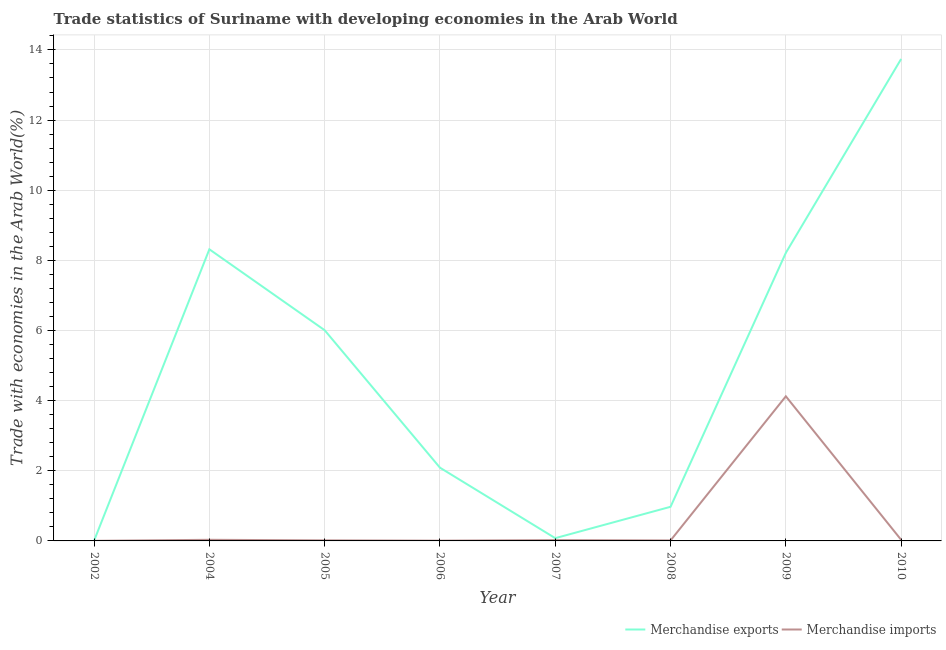How many different coloured lines are there?
Your answer should be very brief. 2. Does the line corresponding to merchandise imports intersect with the line corresponding to merchandise exports?
Offer a very short reply. No. Is the number of lines equal to the number of legend labels?
Provide a short and direct response. Yes. What is the merchandise imports in 2010?
Your response must be concise. 0.03. Across all years, what is the maximum merchandise imports?
Your answer should be compact. 4.12. Across all years, what is the minimum merchandise exports?
Your answer should be very brief. 0.01. In which year was the merchandise imports maximum?
Provide a short and direct response. 2009. In which year was the merchandise imports minimum?
Keep it short and to the point. 2002. What is the total merchandise imports in the graph?
Keep it short and to the point. 4.25. What is the difference between the merchandise imports in 2005 and that in 2006?
Your answer should be very brief. 0.01. What is the difference between the merchandise exports in 2008 and the merchandise imports in 2009?
Give a very brief answer. -3.15. What is the average merchandise exports per year?
Your answer should be compact. 4.93. In the year 2002, what is the difference between the merchandise exports and merchandise imports?
Provide a succinct answer. 0. In how many years, is the merchandise imports greater than 3.2 %?
Make the answer very short. 1. What is the ratio of the merchandise imports in 2005 to that in 2010?
Provide a short and direct response. 0.5. Is the merchandise imports in 2006 less than that in 2009?
Give a very brief answer. Yes. Is the difference between the merchandise imports in 2005 and 2006 greater than the difference between the merchandise exports in 2005 and 2006?
Keep it short and to the point. No. What is the difference between the highest and the second highest merchandise imports?
Provide a short and direct response. 4.09. What is the difference between the highest and the lowest merchandise imports?
Your answer should be very brief. 4.12. In how many years, is the merchandise imports greater than the average merchandise imports taken over all years?
Ensure brevity in your answer.  1. Does the merchandise imports monotonically increase over the years?
Your answer should be compact. No. Is the merchandise exports strictly greater than the merchandise imports over the years?
Your answer should be very brief. Yes. How many lines are there?
Provide a short and direct response. 2. How many years are there in the graph?
Offer a terse response. 8. Are the values on the major ticks of Y-axis written in scientific E-notation?
Keep it short and to the point. No. Does the graph contain any zero values?
Your response must be concise. No. Does the graph contain grids?
Provide a succinct answer. Yes. How many legend labels are there?
Provide a short and direct response. 2. What is the title of the graph?
Ensure brevity in your answer.  Trade statistics of Suriname with developing economies in the Arab World. Does "Under-five" appear as one of the legend labels in the graph?
Offer a terse response. No. What is the label or title of the X-axis?
Offer a very short reply. Year. What is the label or title of the Y-axis?
Offer a very short reply. Trade with economies in the Arab World(%). What is the Trade with economies in the Arab World(%) in Merchandise exports in 2002?
Offer a terse response. 0.01. What is the Trade with economies in the Arab World(%) in Merchandise imports in 2002?
Provide a succinct answer. 0. What is the Trade with economies in the Arab World(%) of Merchandise exports in 2004?
Provide a short and direct response. 8.32. What is the Trade with economies in the Arab World(%) of Merchandise imports in 2004?
Ensure brevity in your answer.  0.03. What is the Trade with economies in the Arab World(%) in Merchandise exports in 2005?
Keep it short and to the point. 6.01. What is the Trade with economies in the Arab World(%) in Merchandise imports in 2005?
Your response must be concise. 0.02. What is the Trade with economies in the Arab World(%) in Merchandise exports in 2006?
Your answer should be compact. 2.09. What is the Trade with economies in the Arab World(%) in Merchandise imports in 2006?
Provide a succinct answer. 0.01. What is the Trade with economies in the Arab World(%) in Merchandise exports in 2007?
Your response must be concise. 0.08. What is the Trade with economies in the Arab World(%) in Merchandise imports in 2007?
Your response must be concise. 0.02. What is the Trade with economies in the Arab World(%) in Merchandise exports in 2008?
Ensure brevity in your answer.  0.97. What is the Trade with economies in the Arab World(%) of Merchandise imports in 2008?
Provide a short and direct response. 0.01. What is the Trade with economies in the Arab World(%) of Merchandise exports in 2009?
Keep it short and to the point. 8.21. What is the Trade with economies in the Arab World(%) of Merchandise imports in 2009?
Your answer should be very brief. 4.12. What is the Trade with economies in the Arab World(%) of Merchandise exports in 2010?
Provide a short and direct response. 13.74. What is the Trade with economies in the Arab World(%) of Merchandise imports in 2010?
Keep it short and to the point. 0.03. Across all years, what is the maximum Trade with economies in the Arab World(%) in Merchandise exports?
Keep it short and to the point. 13.74. Across all years, what is the maximum Trade with economies in the Arab World(%) of Merchandise imports?
Your answer should be compact. 4.12. Across all years, what is the minimum Trade with economies in the Arab World(%) of Merchandise exports?
Offer a very short reply. 0.01. Across all years, what is the minimum Trade with economies in the Arab World(%) in Merchandise imports?
Provide a short and direct response. 0. What is the total Trade with economies in the Arab World(%) of Merchandise exports in the graph?
Ensure brevity in your answer.  39.43. What is the total Trade with economies in the Arab World(%) in Merchandise imports in the graph?
Make the answer very short. 4.25. What is the difference between the Trade with economies in the Arab World(%) in Merchandise exports in 2002 and that in 2004?
Make the answer very short. -8.31. What is the difference between the Trade with economies in the Arab World(%) of Merchandise imports in 2002 and that in 2004?
Ensure brevity in your answer.  -0.03. What is the difference between the Trade with economies in the Arab World(%) in Merchandise exports in 2002 and that in 2005?
Make the answer very short. -6. What is the difference between the Trade with economies in the Arab World(%) in Merchandise imports in 2002 and that in 2005?
Provide a succinct answer. -0.01. What is the difference between the Trade with economies in the Arab World(%) in Merchandise exports in 2002 and that in 2006?
Your answer should be compact. -2.08. What is the difference between the Trade with economies in the Arab World(%) in Merchandise imports in 2002 and that in 2006?
Keep it short and to the point. -0.01. What is the difference between the Trade with economies in the Arab World(%) in Merchandise exports in 2002 and that in 2007?
Give a very brief answer. -0.07. What is the difference between the Trade with economies in the Arab World(%) in Merchandise imports in 2002 and that in 2007?
Your answer should be compact. -0.02. What is the difference between the Trade with economies in the Arab World(%) of Merchandise exports in 2002 and that in 2008?
Ensure brevity in your answer.  -0.97. What is the difference between the Trade with economies in the Arab World(%) in Merchandise imports in 2002 and that in 2008?
Provide a succinct answer. -0.01. What is the difference between the Trade with economies in the Arab World(%) in Merchandise exports in 2002 and that in 2009?
Make the answer very short. -8.21. What is the difference between the Trade with economies in the Arab World(%) in Merchandise imports in 2002 and that in 2009?
Your answer should be compact. -4.12. What is the difference between the Trade with economies in the Arab World(%) in Merchandise exports in 2002 and that in 2010?
Give a very brief answer. -13.74. What is the difference between the Trade with economies in the Arab World(%) in Merchandise imports in 2002 and that in 2010?
Your response must be concise. -0.03. What is the difference between the Trade with economies in the Arab World(%) in Merchandise exports in 2004 and that in 2005?
Your answer should be very brief. 2.31. What is the difference between the Trade with economies in the Arab World(%) in Merchandise imports in 2004 and that in 2005?
Offer a terse response. 0.02. What is the difference between the Trade with economies in the Arab World(%) in Merchandise exports in 2004 and that in 2006?
Provide a short and direct response. 6.23. What is the difference between the Trade with economies in the Arab World(%) of Merchandise imports in 2004 and that in 2006?
Give a very brief answer. 0.02. What is the difference between the Trade with economies in the Arab World(%) in Merchandise exports in 2004 and that in 2007?
Offer a very short reply. 8.24. What is the difference between the Trade with economies in the Arab World(%) of Merchandise imports in 2004 and that in 2007?
Offer a very short reply. 0.01. What is the difference between the Trade with economies in the Arab World(%) of Merchandise exports in 2004 and that in 2008?
Give a very brief answer. 7.34. What is the difference between the Trade with economies in the Arab World(%) in Merchandise imports in 2004 and that in 2008?
Keep it short and to the point. 0.02. What is the difference between the Trade with economies in the Arab World(%) in Merchandise exports in 2004 and that in 2009?
Your answer should be compact. 0.1. What is the difference between the Trade with economies in the Arab World(%) of Merchandise imports in 2004 and that in 2009?
Provide a short and direct response. -4.09. What is the difference between the Trade with economies in the Arab World(%) of Merchandise exports in 2004 and that in 2010?
Give a very brief answer. -5.43. What is the difference between the Trade with economies in the Arab World(%) of Merchandise exports in 2005 and that in 2006?
Give a very brief answer. 3.92. What is the difference between the Trade with economies in the Arab World(%) of Merchandise imports in 2005 and that in 2006?
Keep it short and to the point. 0.01. What is the difference between the Trade with economies in the Arab World(%) in Merchandise exports in 2005 and that in 2007?
Provide a short and direct response. 5.93. What is the difference between the Trade with economies in the Arab World(%) of Merchandise imports in 2005 and that in 2007?
Your answer should be very brief. -0.01. What is the difference between the Trade with economies in the Arab World(%) of Merchandise exports in 2005 and that in 2008?
Ensure brevity in your answer.  5.03. What is the difference between the Trade with economies in the Arab World(%) of Merchandise imports in 2005 and that in 2008?
Provide a short and direct response. 0. What is the difference between the Trade with economies in the Arab World(%) of Merchandise exports in 2005 and that in 2009?
Offer a terse response. -2.21. What is the difference between the Trade with economies in the Arab World(%) of Merchandise imports in 2005 and that in 2009?
Offer a terse response. -4.11. What is the difference between the Trade with economies in the Arab World(%) of Merchandise exports in 2005 and that in 2010?
Keep it short and to the point. -7.73. What is the difference between the Trade with economies in the Arab World(%) of Merchandise imports in 2005 and that in 2010?
Your response must be concise. -0.02. What is the difference between the Trade with economies in the Arab World(%) of Merchandise exports in 2006 and that in 2007?
Offer a very short reply. 2.01. What is the difference between the Trade with economies in the Arab World(%) of Merchandise imports in 2006 and that in 2007?
Give a very brief answer. -0.02. What is the difference between the Trade with economies in the Arab World(%) in Merchandise exports in 2006 and that in 2008?
Offer a very short reply. 1.12. What is the difference between the Trade with economies in the Arab World(%) in Merchandise imports in 2006 and that in 2008?
Provide a succinct answer. -0.01. What is the difference between the Trade with economies in the Arab World(%) in Merchandise exports in 2006 and that in 2009?
Make the answer very short. -6.13. What is the difference between the Trade with economies in the Arab World(%) of Merchandise imports in 2006 and that in 2009?
Your answer should be very brief. -4.12. What is the difference between the Trade with economies in the Arab World(%) in Merchandise exports in 2006 and that in 2010?
Your answer should be compact. -11.65. What is the difference between the Trade with economies in the Arab World(%) in Merchandise imports in 2006 and that in 2010?
Provide a short and direct response. -0.02. What is the difference between the Trade with economies in the Arab World(%) of Merchandise exports in 2007 and that in 2008?
Give a very brief answer. -0.89. What is the difference between the Trade with economies in the Arab World(%) in Merchandise imports in 2007 and that in 2008?
Provide a short and direct response. 0.01. What is the difference between the Trade with economies in the Arab World(%) of Merchandise exports in 2007 and that in 2009?
Your response must be concise. -8.14. What is the difference between the Trade with economies in the Arab World(%) of Merchandise imports in 2007 and that in 2009?
Provide a succinct answer. -4.1. What is the difference between the Trade with economies in the Arab World(%) of Merchandise exports in 2007 and that in 2010?
Your response must be concise. -13.66. What is the difference between the Trade with economies in the Arab World(%) in Merchandise imports in 2007 and that in 2010?
Make the answer very short. -0.01. What is the difference between the Trade with economies in the Arab World(%) of Merchandise exports in 2008 and that in 2009?
Keep it short and to the point. -7.24. What is the difference between the Trade with economies in the Arab World(%) of Merchandise imports in 2008 and that in 2009?
Your answer should be very brief. -4.11. What is the difference between the Trade with economies in the Arab World(%) in Merchandise exports in 2008 and that in 2010?
Give a very brief answer. -12.77. What is the difference between the Trade with economies in the Arab World(%) in Merchandise imports in 2008 and that in 2010?
Your answer should be very brief. -0.02. What is the difference between the Trade with economies in the Arab World(%) of Merchandise exports in 2009 and that in 2010?
Your answer should be compact. -5.53. What is the difference between the Trade with economies in the Arab World(%) in Merchandise imports in 2009 and that in 2010?
Give a very brief answer. 4.09. What is the difference between the Trade with economies in the Arab World(%) of Merchandise exports in 2002 and the Trade with economies in the Arab World(%) of Merchandise imports in 2004?
Provide a short and direct response. -0.03. What is the difference between the Trade with economies in the Arab World(%) in Merchandise exports in 2002 and the Trade with economies in the Arab World(%) in Merchandise imports in 2005?
Keep it short and to the point. -0.01. What is the difference between the Trade with economies in the Arab World(%) of Merchandise exports in 2002 and the Trade with economies in the Arab World(%) of Merchandise imports in 2006?
Offer a very short reply. -0. What is the difference between the Trade with economies in the Arab World(%) in Merchandise exports in 2002 and the Trade with economies in the Arab World(%) in Merchandise imports in 2007?
Offer a terse response. -0.02. What is the difference between the Trade with economies in the Arab World(%) in Merchandise exports in 2002 and the Trade with economies in the Arab World(%) in Merchandise imports in 2008?
Make the answer very short. -0.01. What is the difference between the Trade with economies in the Arab World(%) in Merchandise exports in 2002 and the Trade with economies in the Arab World(%) in Merchandise imports in 2009?
Offer a terse response. -4.12. What is the difference between the Trade with economies in the Arab World(%) in Merchandise exports in 2002 and the Trade with economies in the Arab World(%) in Merchandise imports in 2010?
Offer a very short reply. -0.03. What is the difference between the Trade with economies in the Arab World(%) of Merchandise exports in 2004 and the Trade with economies in the Arab World(%) of Merchandise imports in 2005?
Give a very brief answer. 8.3. What is the difference between the Trade with economies in the Arab World(%) of Merchandise exports in 2004 and the Trade with economies in the Arab World(%) of Merchandise imports in 2006?
Provide a short and direct response. 8.31. What is the difference between the Trade with economies in the Arab World(%) of Merchandise exports in 2004 and the Trade with economies in the Arab World(%) of Merchandise imports in 2007?
Make the answer very short. 8.29. What is the difference between the Trade with economies in the Arab World(%) in Merchandise exports in 2004 and the Trade with economies in the Arab World(%) in Merchandise imports in 2008?
Your answer should be compact. 8.3. What is the difference between the Trade with economies in the Arab World(%) in Merchandise exports in 2004 and the Trade with economies in the Arab World(%) in Merchandise imports in 2009?
Make the answer very short. 4.19. What is the difference between the Trade with economies in the Arab World(%) of Merchandise exports in 2004 and the Trade with economies in the Arab World(%) of Merchandise imports in 2010?
Your answer should be compact. 8.28. What is the difference between the Trade with economies in the Arab World(%) of Merchandise exports in 2005 and the Trade with economies in the Arab World(%) of Merchandise imports in 2006?
Your response must be concise. 6. What is the difference between the Trade with economies in the Arab World(%) in Merchandise exports in 2005 and the Trade with economies in the Arab World(%) in Merchandise imports in 2007?
Give a very brief answer. 5.98. What is the difference between the Trade with economies in the Arab World(%) of Merchandise exports in 2005 and the Trade with economies in the Arab World(%) of Merchandise imports in 2008?
Provide a short and direct response. 5.99. What is the difference between the Trade with economies in the Arab World(%) of Merchandise exports in 2005 and the Trade with economies in the Arab World(%) of Merchandise imports in 2009?
Make the answer very short. 1.88. What is the difference between the Trade with economies in the Arab World(%) of Merchandise exports in 2005 and the Trade with economies in the Arab World(%) of Merchandise imports in 2010?
Provide a succinct answer. 5.98. What is the difference between the Trade with economies in the Arab World(%) in Merchandise exports in 2006 and the Trade with economies in the Arab World(%) in Merchandise imports in 2007?
Provide a succinct answer. 2.06. What is the difference between the Trade with economies in the Arab World(%) in Merchandise exports in 2006 and the Trade with economies in the Arab World(%) in Merchandise imports in 2008?
Your response must be concise. 2.07. What is the difference between the Trade with economies in the Arab World(%) in Merchandise exports in 2006 and the Trade with economies in the Arab World(%) in Merchandise imports in 2009?
Your answer should be compact. -2.03. What is the difference between the Trade with economies in the Arab World(%) of Merchandise exports in 2006 and the Trade with economies in the Arab World(%) of Merchandise imports in 2010?
Provide a short and direct response. 2.06. What is the difference between the Trade with economies in the Arab World(%) in Merchandise exports in 2007 and the Trade with economies in the Arab World(%) in Merchandise imports in 2008?
Your answer should be very brief. 0.06. What is the difference between the Trade with economies in the Arab World(%) in Merchandise exports in 2007 and the Trade with economies in the Arab World(%) in Merchandise imports in 2009?
Make the answer very short. -4.04. What is the difference between the Trade with economies in the Arab World(%) of Merchandise exports in 2007 and the Trade with economies in the Arab World(%) of Merchandise imports in 2010?
Your answer should be very brief. 0.05. What is the difference between the Trade with economies in the Arab World(%) of Merchandise exports in 2008 and the Trade with economies in the Arab World(%) of Merchandise imports in 2009?
Provide a succinct answer. -3.15. What is the difference between the Trade with economies in the Arab World(%) in Merchandise exports in 2009 and the Trade with economies in the Arab World(%) in Merchandise imports in 2010?
Make the answer very short. 8.18. What is the average Trade with economies in the Arab World(%) in Merchandise exports per year?
Your answer should be very brief. 4.93. What is the average Trade with economies in the Arab World(%) in Merchandise imports per year?
Ensure brevity in your answer.  0.53. In the year 2002, what is the difference between the Trade with economies in the Arab World(%) of Merchandise exports and Trade with economies in the Arab World(%) of Merchandise imports?
Your response must be concise. 0. In the year 2004, what is the difference between the Trade with economies in the Arab World(%) of Merchandise exports and Trade with economies in the Arab World(%) of Merchandise imports?
Provide a succinct answer. 8.28. In the year 2005, what is the difference between the Trade with economies in the Arab World(%) of Merchandise exports and Trade with economies in the Arab World(%) of Merchandise imports?
Your answer should be very brief. 5.99. In the year 2006, what is the difference between the Trade with economies in the Arab World(%) of Merchandise exports and Trade with economies in the Arab World(%) of Merchandise imports?
Keep it short and to the point. 2.08. In the year 2007, what is the difference between the Trade with economies in the Arab World(%) of Merchandise exports and Trade with economies in the Arab World(%) of Merchandise imports?
Keep it short and to the point. 0.06. In the year 2008, what is the difference between the Trade with economies in the Arab World(%) in Merchandise exports and Trade with economies in the Arab World(%) in Merchandise imports?
Provide a short and direct response. 0.96. In the year 2009, what is the difference between the Trade with economies in the Arab World(%) of Merchandise exports and Trade with economies in the Arab World(%) of Merchandise imports?
Provide a short and direct response. 4.09. In the year 2010, what is the difference between the Trade with economies in the Arab World(%) in Merchandise exports and Trade with economies in the Arab World(%) in Merchandise imports?
Ensure brevity in your answer.  13.71. What is the ratio of the Trade with economies in the Arab World(%) of Merchandise exports in 2002 to that in 2004?
Provide a succinct answer. 0. What is the ratio of the Trade with economies in the Arab World(%) in Merchandise imports in 2002 to that in 2004?
Ensure brevity in your answer.  0.08. What is the ratio of the Trade with economies in the Arab World(%) in Merchandise imports in 2002 to that in 2005?
Ensure brevity in your answer.  0.16. What is the ratio of the Trade with economies in the Arab World(%) of Merchandise exports in 2002 to that in 2006?
Give a very brief answer. 0. What is the ratio of the Trade with economies in the Arab World(%) of Merchandise imports in 2002 to that in 2006?
Make the answer very short. 0.32. What is the ratio of the Trade with economies in the Arab World(%) of Merchandise exports in 2002 to that in 2007?
Your answer should be compact. 0.07. What is the ratio of the Trade with economies in the Arab World(%) of Merchandise imports in 2002 to that in 2007?
Provide a succinct answer. 0.11. What is the ratio of the Trade with economies in the Arab World(%) of Merchandise exports in 2002 to that in 2008?
Your response must be concise. 0.01. What is the ratio of the Trade with economies in the Arab World(%) of Merchandise imports in 2002 to that in 2008?
Keep it short and to the point. 0.18. What is the ratio of the Trade with economies in the Arab World(%) in Merchandise exports in 2002 to that in 2009?
Make the answer very short. 0. What is the ratio of the Trade with economies in the Arab World(%) of Merchandise imports in 2002 to that in 2009?
Ensure brevity in your answer.  0. What is the ratio of the Trade with economies in the Arab World(%) in Merchandise exports in 2002 to that in 2010?
Offer a very short reply. 0. What is the ratio of the Trade with economies in the Arab World(%) of Merchandise imports in 2002 to that in 2010?
Give a very brief answer. 0.08. What is the ratio of the Trade with economies in the Arab World(%) of Merchandise exports in 2004 to that in 2005?
Give a very brief answer. 1.38. What is the ratio of the Trade with economies in the Arab World(%) of Merchandise imports in 2004 to that in 2005?
Make the answer very short. 2.01. What is the ratio of the Trade with economies in the Arab World(%) of Merchandise exports in 2004 to that in 2006?
Provide a short and direct response. 3.98. What is the ratio of the Trade with economies in the Arab World(%) in Merchandise imports in 2004 to that in 2006?
Your response must be concise. 4.13. What is the ratio of the Trade with economies in the Arab World(%) of Merchandise exports in 2004 to that in 2007?
Your answer should be compact. 105.72. What is the ratio of the Trade with economies in the Arab World(%) in Merchandise imports in 2004 to that in 2007?
Make the answer very short. 1.36. What is the ratio of the Trade with economies in the Arab World(%) of Merchandise exports in 2004 to that in 2008?
Your answer should be very brief. 8.54. What is the ratio of the Trade with economies in the Arab World(%) in Merchandise imports in 2004 to that in 2008?
Offer a terse response. 2.3. What is the ratio of the Trade with economies in the Arab World(%) in Merchandise exports in 2004 to that in 2009?
Provide a succinct answer. 1.01. What is the ratio of the Trade with economies in the Arab World(%) in Merchandise imports in 2004 to that in 2009?
Offer a terse response. 0.01. What is the ratio of the Trade with economies in the Arab World(%) of Merchandise exports in 2004 to that in 2010?
Make the answer very short. 0.61. What is the ratio of the Trade with economies in the Arab World(%) in Merchandise exports in 2005 to that in 2006?
Make the answer very short. 2.88. What is the ratio of the Trade with economies in the Arab World(%) in Merchandise imports in 2005 to that in 2006?
Your answer should be compact. 2.06. What is the ratio of the Trade with economies in the Arab World(%) in Merchandise exports in 2005 to that in 2007?
Keep it short and to the point. 76.39. What is the ratio of the Trade with economies in the Arab World(%) of Merchandise imports in 2005 to that in 2007?
Your answer should be compact. 0.68. What is the ratio of the Trade with economies in the Arab World(%) in Merchandise exports in 2005 to that in 2008?
Provide a succinct answer. 6.17. What is the ratio of the Trade with economies in the Arab World(%) of Merchandise imports in 2005 to that in 2008?
Give a very brief answer. 1.15. What is the ratio of the Trade with economies in the Arab World(%) in Merchandise exports in 2005 to that in 2009?
Provide a succinct answer. 0.73. What is the ratio of the Trade with economies in the Arab World(%) in Merchandise imports in 2005 to that in 2009?
Provide a short and direct response. 0. What is the ratio of the Trade with economies in the Arab World(%) of Merchandise exports in 2005 to that in 2010?
Keep it short and to the point. 0.44. What is the ratio of the Trade with economies in the Arab World(%) in Merchandise imports in 2005 to that in 2010?
Your answer should be compact. 0.5. What is the ratio of the Trade with economies in the Arab World(%) of Merchandise exports in 2006 to that in 2007?
Provide a succinct answer. 26.55. What is the ratio of the Trade with economies in the Arab World(%) of Merchandise imports in 2006 to that in 2007?
Offer a terse response. 0.33. What is the ratio of the Trade with economies in the Arab World(%) of Merchandise exports in 2006 to that in 2008?
Your answer should be very brief. 2.15. What is the ratio of the Trade with economies in the Arab World(%) in Merchandise imports in 2006 to that in 2008?
Your answer should be compact. 0.56. What is the ratio of the Trade with economies in the Arab World(%) of Merchandise exports in 2006 to that in 2009?
Your response must be concise. 0.25. What is the ratio of the Trade with economies in the Arab World(%) in Merchandise imports in 2006 to that in 2009?
Provide a succinct answer. 0. What is the ratio of the Trade with economies in the Arab World(%) of Merchandise exports in 2006 to that in 2010?
Your response must be concise. 0.15. What is the ratio of the Trade with economies in the Arab World(%) of Merchandise imports in 2006 to that in 2010?
Make the answer very short. 0.24. What is the ratio of the Trade with economies in the Arab World(%) in Merchandise exports in 2007 to that in 2008?
Give a very brief answer. 0.08. What is the ratio of the Trade with economies in the Arab World(%) in Merchandise imports in 2007 to that in 2008?
Ensure brevity in your answer.  1.69. What is the ratio of the Trade with economies in the Arab World(%) in Merchandise exports in 2007 to that in 2009?
Make the answer very short. 0.01. What is the ratio of the Trade with economies in the Arab World(%) in Merchandise imports in 2007 to that in 2009?
Keep it short and to the point. 0.01. What is the ratio of the Trade with economies in the Arab World(%) of Merchandise exports in 2007 to that in 2010?
Your response must be concise. 0.01. What is the ratio of the Trade with economies in the Arab World(%) of Merchandise imports in 2007 to that in 2010?
Provide a short and direct response. 0.74. What is the ratio of the Trade with economies in the Arab World(%) in Merchandise exports in 2008 to that in 2009?
Offer a terse response. 0.12. What is the ratio of the Trade with economies in the Arab World(%) in Merchandise imports in 2008 to that in 2009?
Give a very brief answer. 0. What is the ratio of the Trade with economies in the Arab World(%) of Merchandise exports in 2008 to that in 2010?
Your answer should be very brief. 0.07. What is the ratio of the Trade with economies in the Arab World(%) of Merchandise imports in 2008 to that in 2010?
Offer a very short reply. 0.43. What is the ratio of the Trade with economies in the Arab World(%) of Merchandise exports in 2009 to that in 2010?
Your answer should be compact. 0.6. What is the ratio of the Trade with economies in the Arab World(%) in Merchandise imports in 2009 to that in 2010?
Provide a short and direct response. 128.82. What is the difference between the highest and the second highest Trade with economies in the Arab World(%) of Merchandise exports?
Your answer should be very brief. 5.43. What is the difference between the highest and the second highest Trade with economies in the Arab World(%) in Merchandise imports?
Your answer should be compact. 4.09. What is the difference between the highest and the lowest Trade with economies in the Arab World(%) of Merchandise exports?
Offer a terse response. 13.74. What is the difference between the highest and the lowest Trade with economies in the Arab World(%) of Merchandise imports?
Keep it short and to the point. 4.12. 